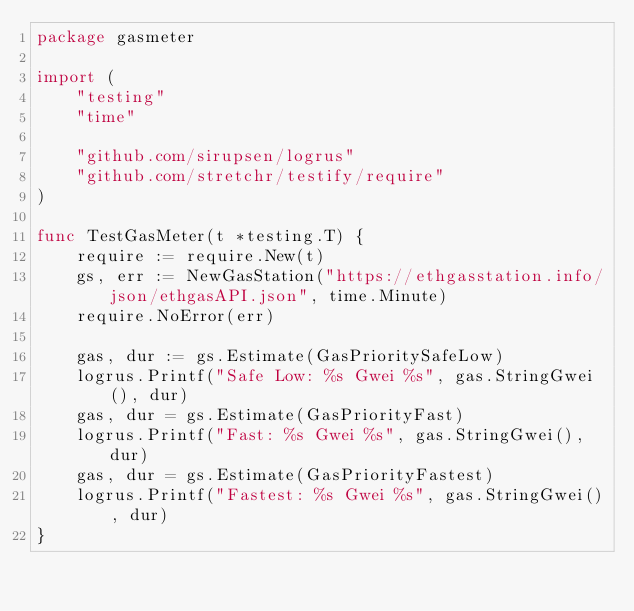Convert code to text. <code><loc_0><loc_0><loc_500><loc_500><_Go_>package gasmeter

import (
	"testing"
	"time"

	"github.com/sirupsen/logrus"
	"github.com/stretchr/testify/require"
)

func TestGasMeter(t *testing.T) {
	require := require.New(t)
	gs, err := NewGasStation("https://ethgasstation.info/json/ethgasAPI.json", time.Minute)
	require.NoError(err)

	gas, dur := gs.Estimate(GasPrioritySafeLow)
	logrus.Printf("Safe Low: %s Gwei %s", gas.StringGwei(), dur)
	gas, dur = gs.Estimate(GasPriorityFast)
	logrus.Printf("Fast: %s Gwei %s", gas.StringGwei(), dur)
	gas, dur = gs.Estimate(GasPriorityFastest)
	logrus.Printf("Fastest: %s Gwei %s", gas.StringGwei(), dur)
}
</code> 